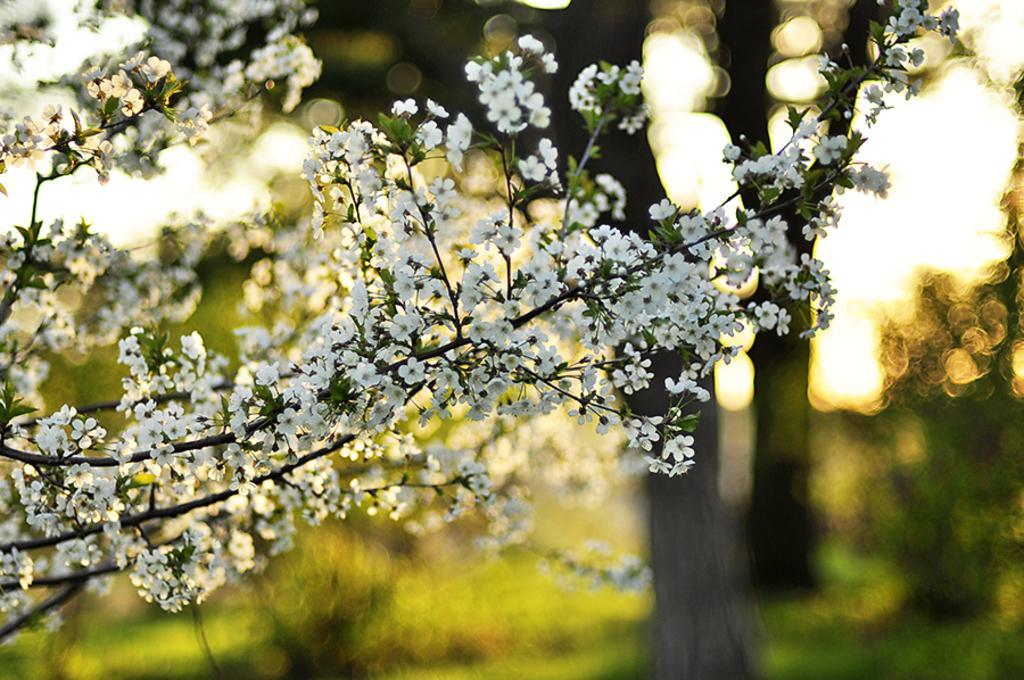Please provide a concise description of this image. Here we can see a plant with flowers and in the background the image is blur. 